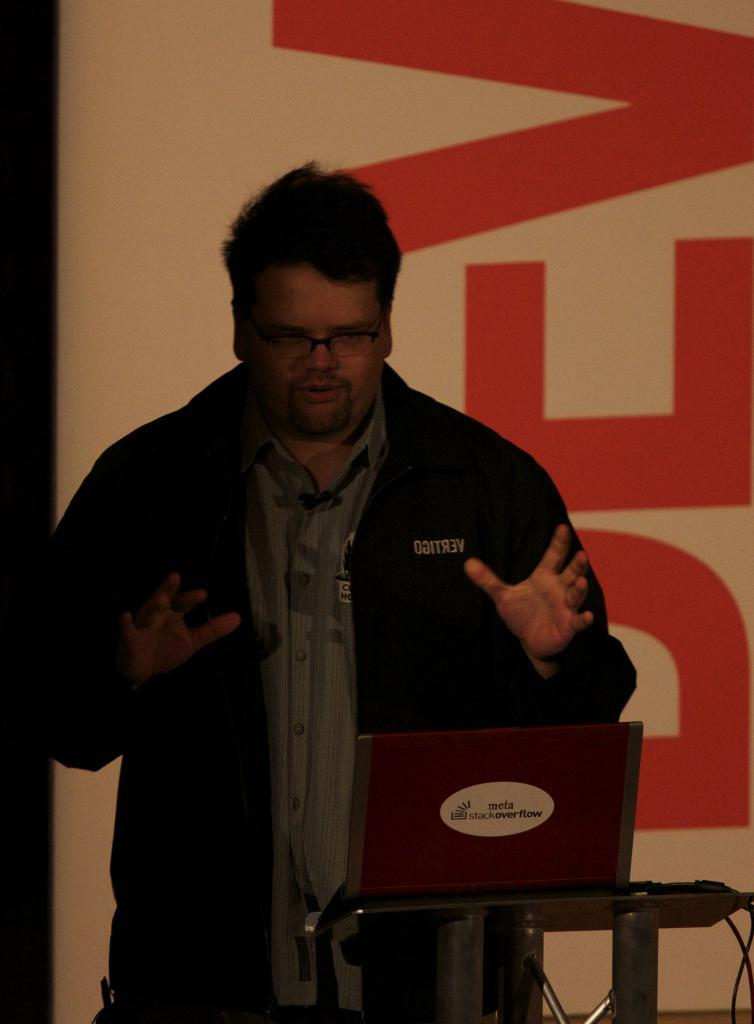What is the main subject in the foreground of the image? There is a person in the foreground of the image. What is the person standing in front of? The person is standing in front of a table. What object is on the table? There is a laptop on the table. What can be seen in the background of the image? In the background, there appears to be a screen. What type of insurance is being discussed by the person in the image? There is no indication in the image that the person is discussing insurance, as the focus is on their position in front of a table with a laptop and a screen in the background. 